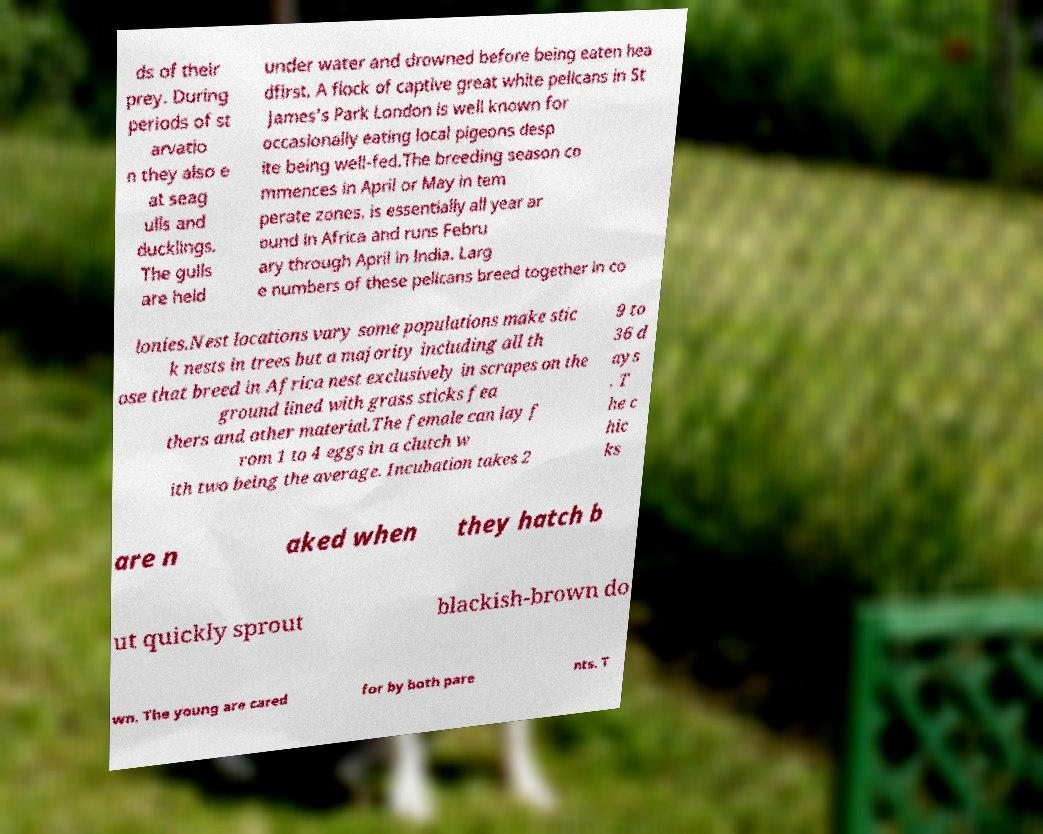There's text embedded in this image that I need extracted. Can you transcribe it verbatim? ds of their prey. During periods of st arvatio n they also e at seag ulls and ducklings. The gulls are held under water and drowned before being eaten hea dfirst. A flock of captive great white pelicans in St James's Park London is well known for occasionally eating local pigeons desp ite being well-fed.The breeding season co mmences in April or May in tem perate zones, is essentially all year ar ound in Africa and runs Febru ary through April in India. Larg e numbers of these pelicans breed together in co lonies.Nest locations vary some populations make stic k nests in trees but a majority including all th ose that breed in Africa nest exclusively in scrapes on the ground lined with grass sticks fea thers and other material.The female can lay f rom 1 to 4 eggs in a clutch w ith two being the average. Incubation takes 2 9 to 36 d ays . T he c hic ks are n aked when they hatch b ut quickly sprout blackish-brown do wn. The young are cared for by both pare nts. T 